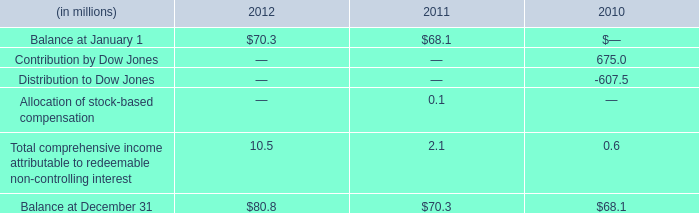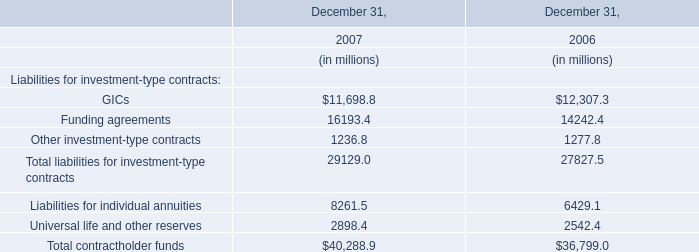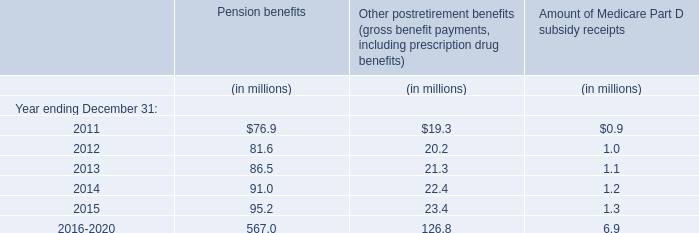what is the percentage change in the balance of non-controlling interests from 2011 to 2012? 
Computations: ((80.8 - 70.3) / 80.8)
Answer: 0.12995. 